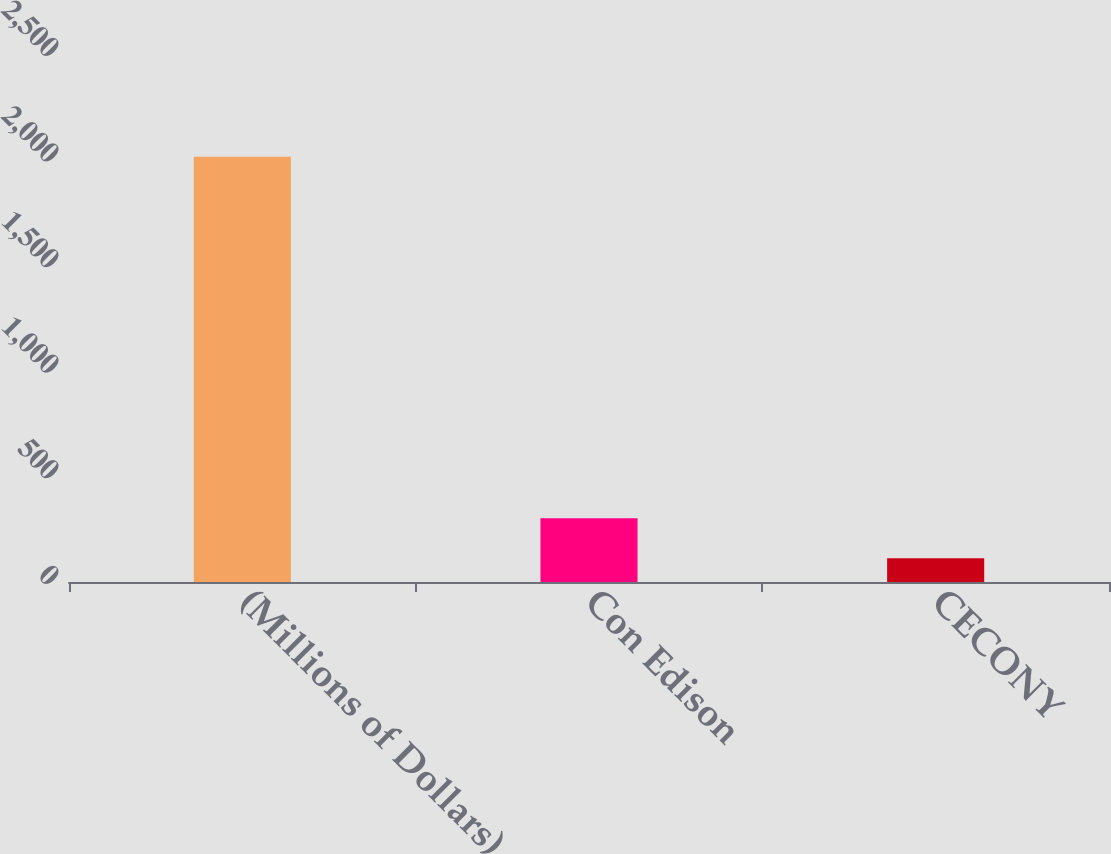<chart> <loc_0><loc_0><loc_500><loc_500><bar_chart><fcel>(Millions of Dollars)<fcel>Con Edison<fcel>CECONY<nl><fcel>2013<fcel>302.1<fcel>112<nl></chart> 